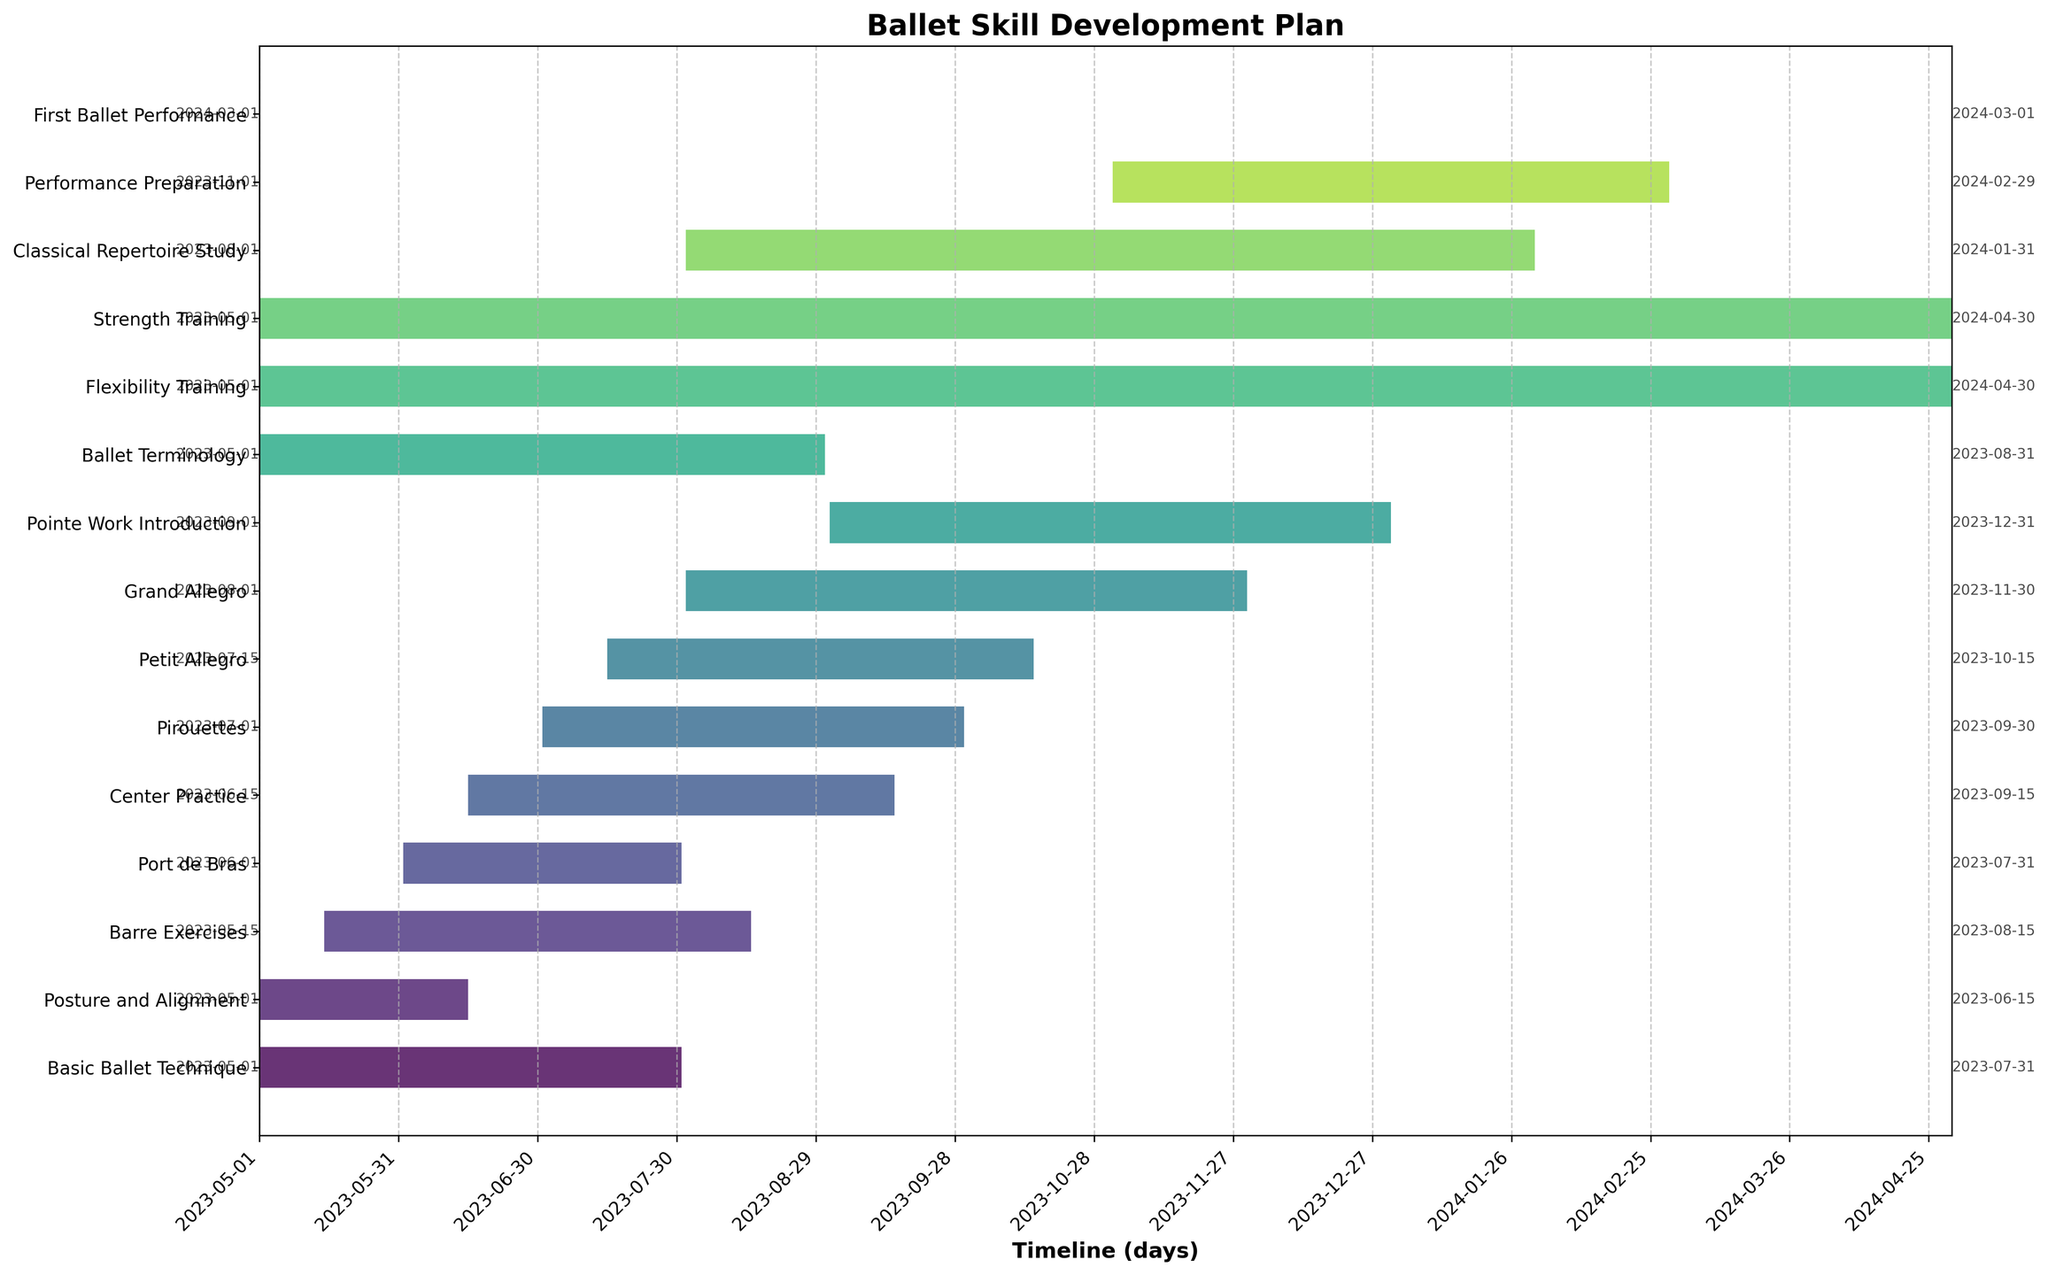What is the title of the Gantt Chart? The title of the chart is usually positioned at the top of the graph and can be read directly without any further calculations or interpretations.
Answer: Ballet Skill Development Plan How many weeks does the Flexibility Training task last? In the Gantt Chart, locate the Flexibility Training task and refer to its duration value, which is given directly in weeks.
Answer: 52 weeks Which training starts first, Basic Ballet Technique or Ballet Terminology? Identify the start dates for both Basic Ballet Technique and Ballet Terminology and compare them. Both start on 2023-05-01; thus, they start at the same time.
Answer: Both start at the same time How long is the overall project duration in days? To find the overall project duration, calculate the difference between the earliest start date (2023-05-01) and the latest end date (2024-04-30) across all tasks. The duration is 365 days.
Answer: 365 days When does the task Pirouettes end? Look for the Pirouettes task and read off its end date from the chart.
Answer: 2023-09-30 What is the total duration of the Barre Exercises and Petit Allegro tasks combined? Locate the duration for each task: Barre Exercises is 13 weeks, and Petit Allegro is 13 weeks. Add these durations together: 13 weeks + 13 weeks = 26 weeks.
Answer: 26 weeks Which task has the shortest duration and how long is it? Identify the task with the shortest bar in the Gantt Chart. The task "First Ballet Performance" has a duration of 1 day.
Answer: First Ballet Performance, 1 day How many tasks last for exactly 13 weeks? From the Gantt Chart, count the tasks with a duration of exactly 13 weeks. Basic Ballet Technique, Barre Exercises, Center Practice, Pirouettes, and Petit Allegro all have a duration of 13 weeks.
Answer: 5 tasks Which two tasks overlap during the entire month of July 2023? Examine the timeline for July 2023 and identify tasks that span the entire month. Basic Ballet Technique (May 1 - July 31) and Port de Bras (June 1 - July 31) are both active during this period.
Answer: Basic Ballet Technique and Port de Bras 